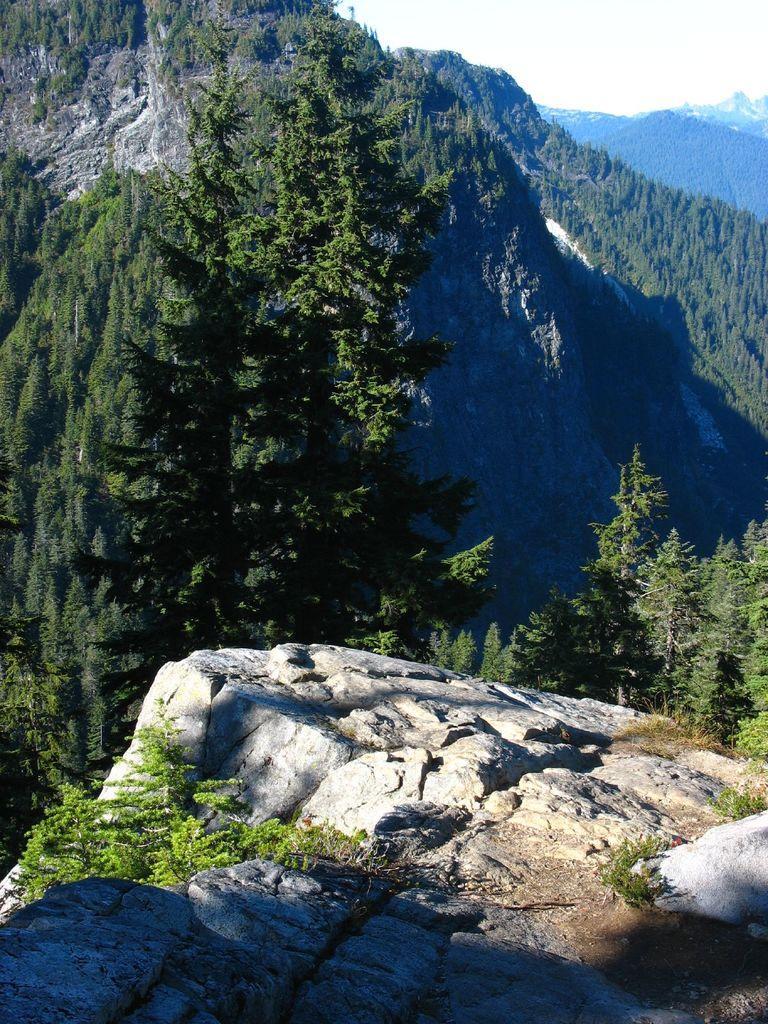In one or two sentences, can you explain what this image depicts? In this image we can see so many trees on the mountains and the sky is in white color. 